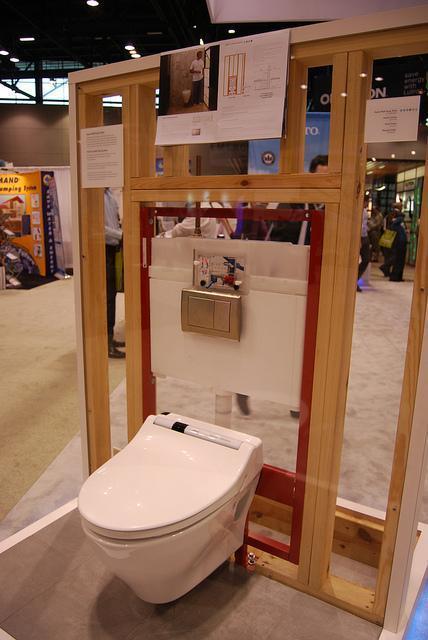Where is this toilet located?
Indicate the correct choice and explain in the format: 'Answer: answer
Rationale: rationale.'
Options: Car, bathroom, kitchen, expo. Answer: expo.
Rationale: It appears to be an a place for people to look at it on display. 